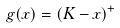<formula> <loc_0><loc_0><loc_500><loc_500>g ( x ) = ( K - x ) ^ { + }</formula> 